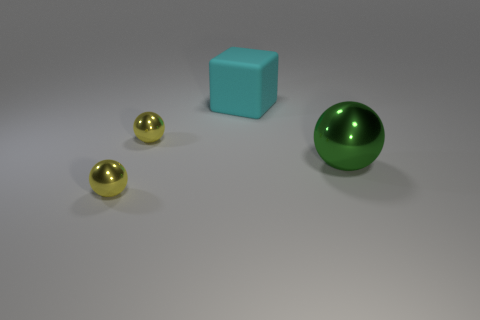Which objects in the image seem to reflect light more intensely? The two golden spheres seem to reflect the light more intensely, as indicated by the bright highlights and sharp reflections on their surfaces. 